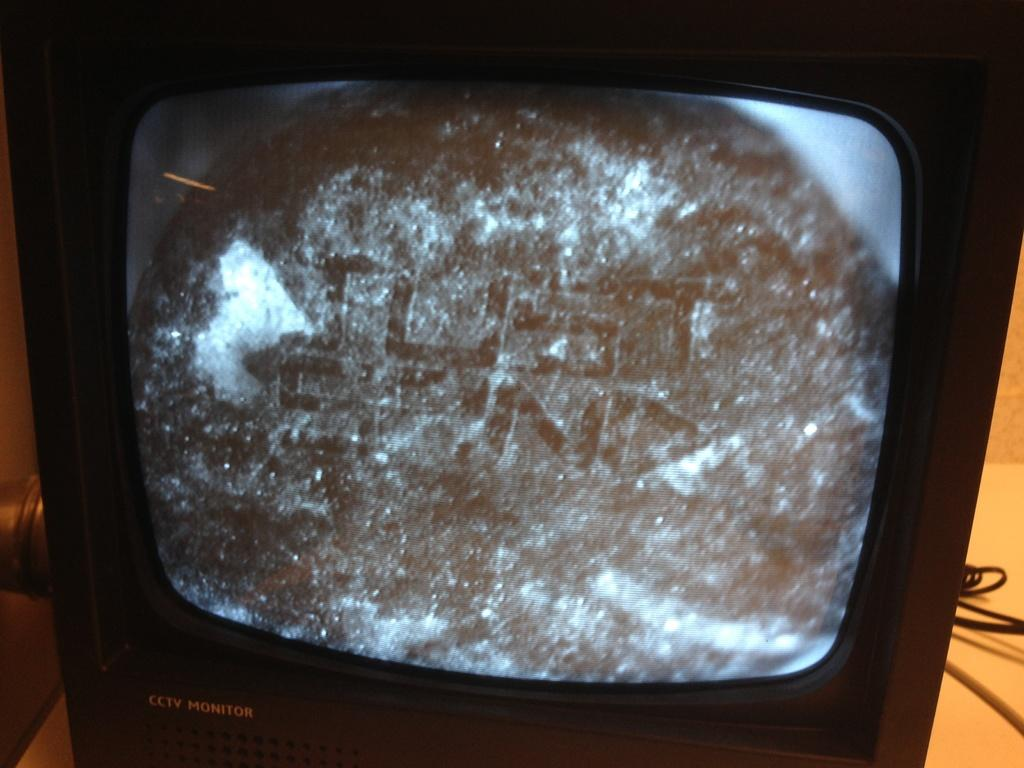<image>
Create a compact narrative representing the image presented. A small television serves as a cctv (closed circuit television) monitor. 